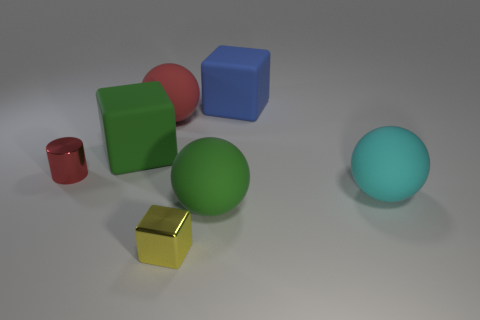Subtract all big rubber cubes. How many cubes are left? 1 Add 2 tiny yellow cubes. How many objects exist? 9 Subtract all cyan balls. How many balls are left? 2 Subtract all spheres. How many objects are left? 4 Subtract 3 balls. How many balls are left? 0 Subtract all red blocks. Subtract all yellow cylinders. How many blocks are left? 3 Subtract all yellow cubes. How many red spheres are left? 1 Subtract all large red things. Subtract all small blue metal blocks. How many objects are left? 6 Add 4 yellow metallic cubes. How many yellow metallic cubes are left? 5 Add 1 tiny red shiny cylinders. How many tiny red shiny cylinders exist? 2 